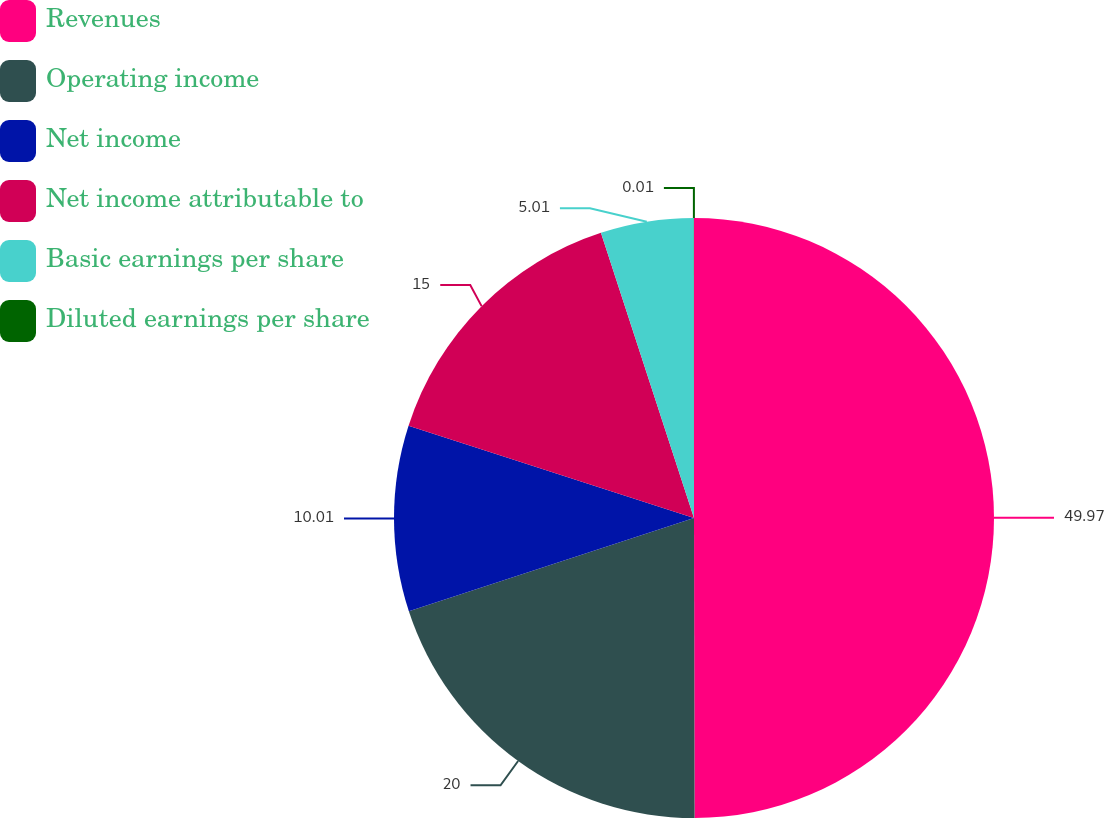Convert chart. <chart><loc_0><loc_0><loc_500><loc_500><pie_chart><fcel>Revenues<fcel>Operating income<fcel>Net income<fcel>Net income attributable to<fcel>Basic earnings per share<fcel>Diluted earnings per share<nl><fcel>49.97%<fcel>20.0%<fcel>10.01%<fcel>15.0%<fcel>5.01%<fcel>0.01%<nl></chart> 